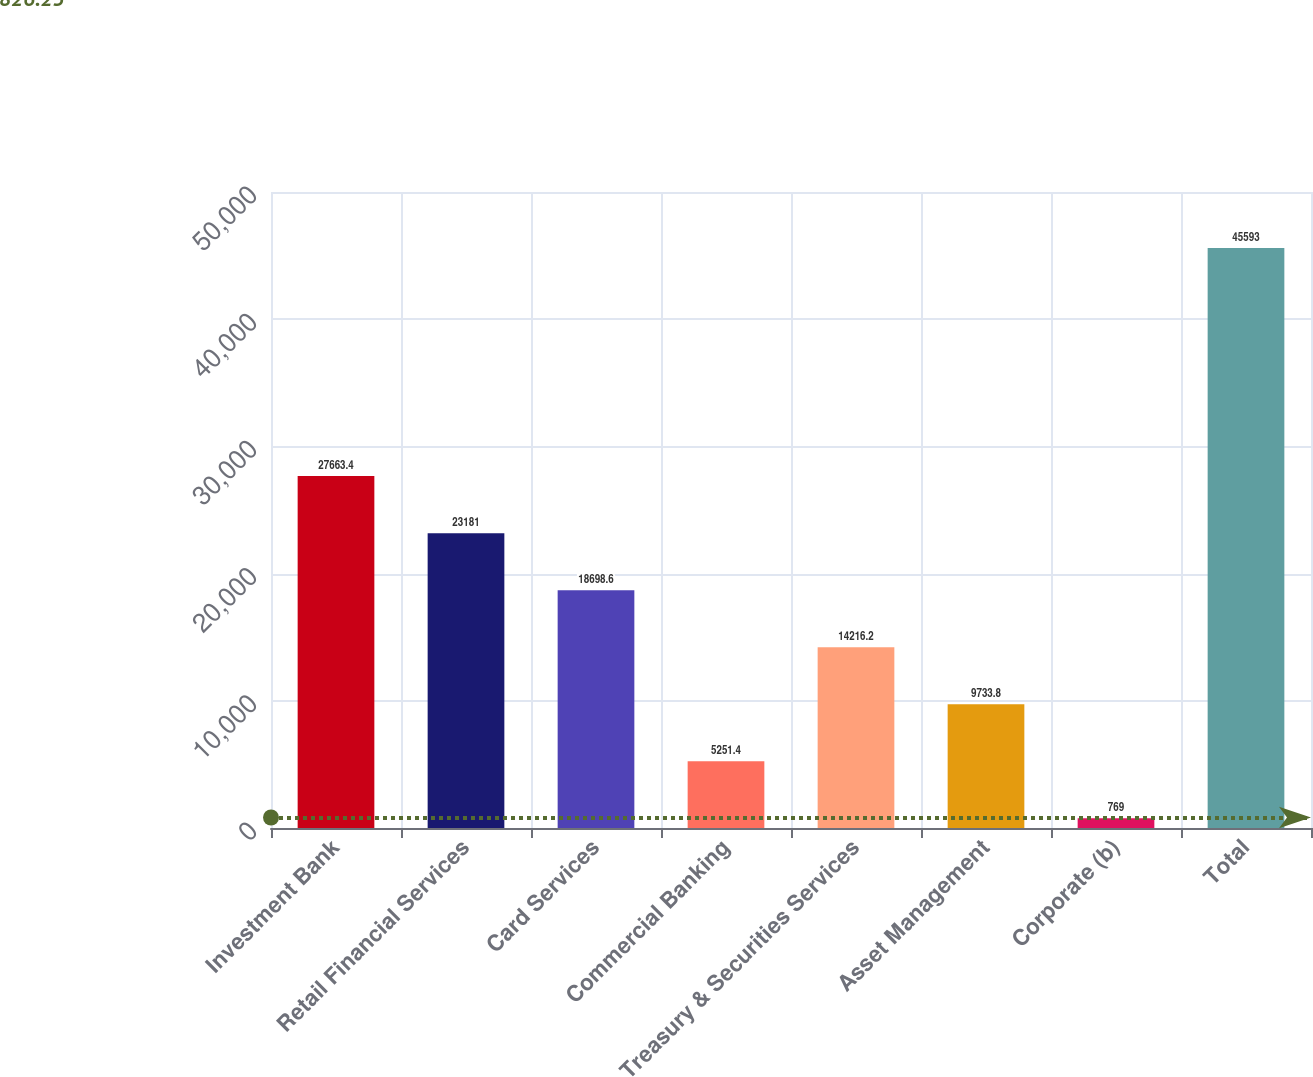<chart> <loc_0><loc_0><loc_500><loc_500><bar_chart><fcel>Investment Bank<fcel>Retail Financial Services<fcel>Card Services<fcel>Commercial Banking<fcel>Treasury & Securities Services<fcel>Asset Management<fcel>Corporate (b)<fcel>Total<nl><fcel>27663.4<fcel>23181<fcel>18698.6<fcel>5251.4<fcel>14216.2<fcel>9733.8<fcel>769<fcel>45593<nl></chart> 